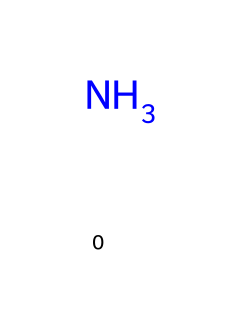what is the total number of atoms in ammonia? The chemical structure shows one nitrogen atom and three hydrogen atoms bonded to it, resulting in a total of 4 atoms.
Answer: 4 what type of bonds are present in ammonia? Ammonia has single covalent bonds between the nitrogen atom and each of the three hydrogen atoms.
Answer: single covalent bonds how many hydrogen atoms are attached to the nitrogen in ammonia? By examining the structure, we see that there are three hydrogen atoms directly bonded to the nitrogen atom.
Answer: 3 what is the molecular formula for ammonia? The structure consists of one nitrogen and three hydrogen atoms, leading to the molecular formula NH3.
Answer: NH3 what property of ammonia allows it to act as a cleaning agent? The presence of the nitrogen atom with a lone pair makes ammonia a good base, which allows it to react with acids and help dissolve dirt.
Answer: base why does ammonia have a pungent odor? The nitrogen atom in ammonia contributes to its volatility and the loose bonding allows ammonia molecules to easily escape into the air, causing a strong odor.
Answer: volatility what makes ammonia a base in cleaning products? Ammonia contains a nitrogen atom with a lone pair that can accept protons, making it a Brønsted-Lowry base.
Answer: lone pair 